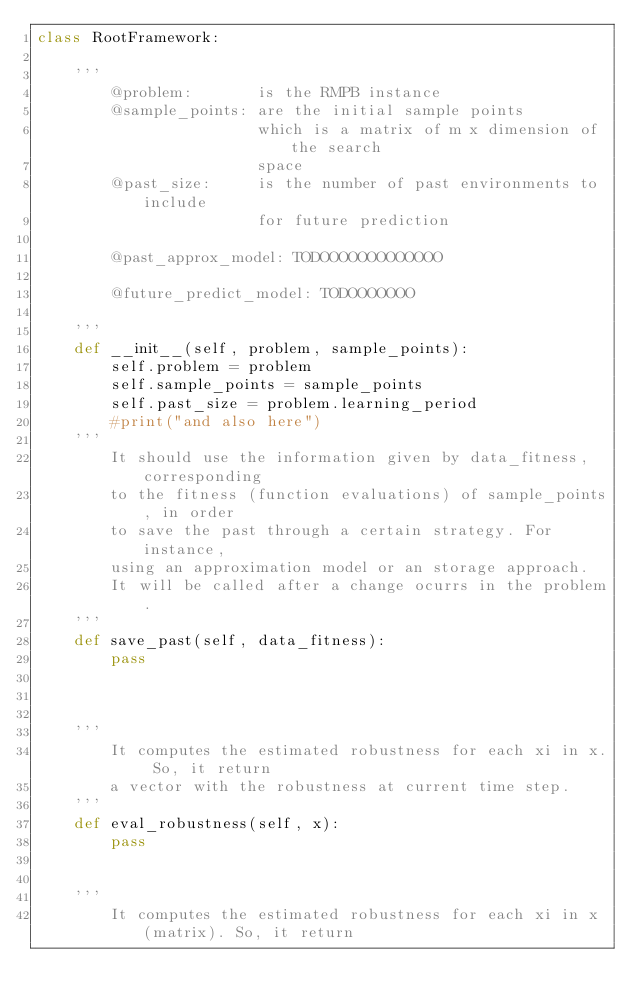Convert code to text. <code><loc_0><loc_0><loc_500><loc_500><_Python_>class RootFramework:

    '''
        @problem:       is the RMPB instance
        @sample_points: are the initial sample points
                        which is a matrix of m x dimension of the search
                        space
        @past_size:     is the number of past environments to include
                        for future prediction

        @past_approx_model: TODOOOOOOOOOOOOO

        @future_predict_model: TODOOOOOOO

    '''
    def __init__(self, problem, sample_points):
        self.problem = problem
        self.sample_points = sample_points
        self.past_size = problem.learning_period
        #print("and also here")
    '''
        It should use the information given by data_fitness, corresponding
        to the fitness (function evaluations) of sample_points, in order
        to save the past through a certain strategy. For instance,
        using an approximation model or an storage approach.
        It will be called after a change ocurrs in the problem.
    '''
    def save_past(self, data_fitness):
        pass



    '''
        It computes the estimated robustness for each xi in x. So, it return
        a vector with the robustness at current time step.
    '''
    def eval_robustness(self, x):
        pass


    '''
        It computes the estimated robustness for each xi in x (matrix). So, it return</code> 